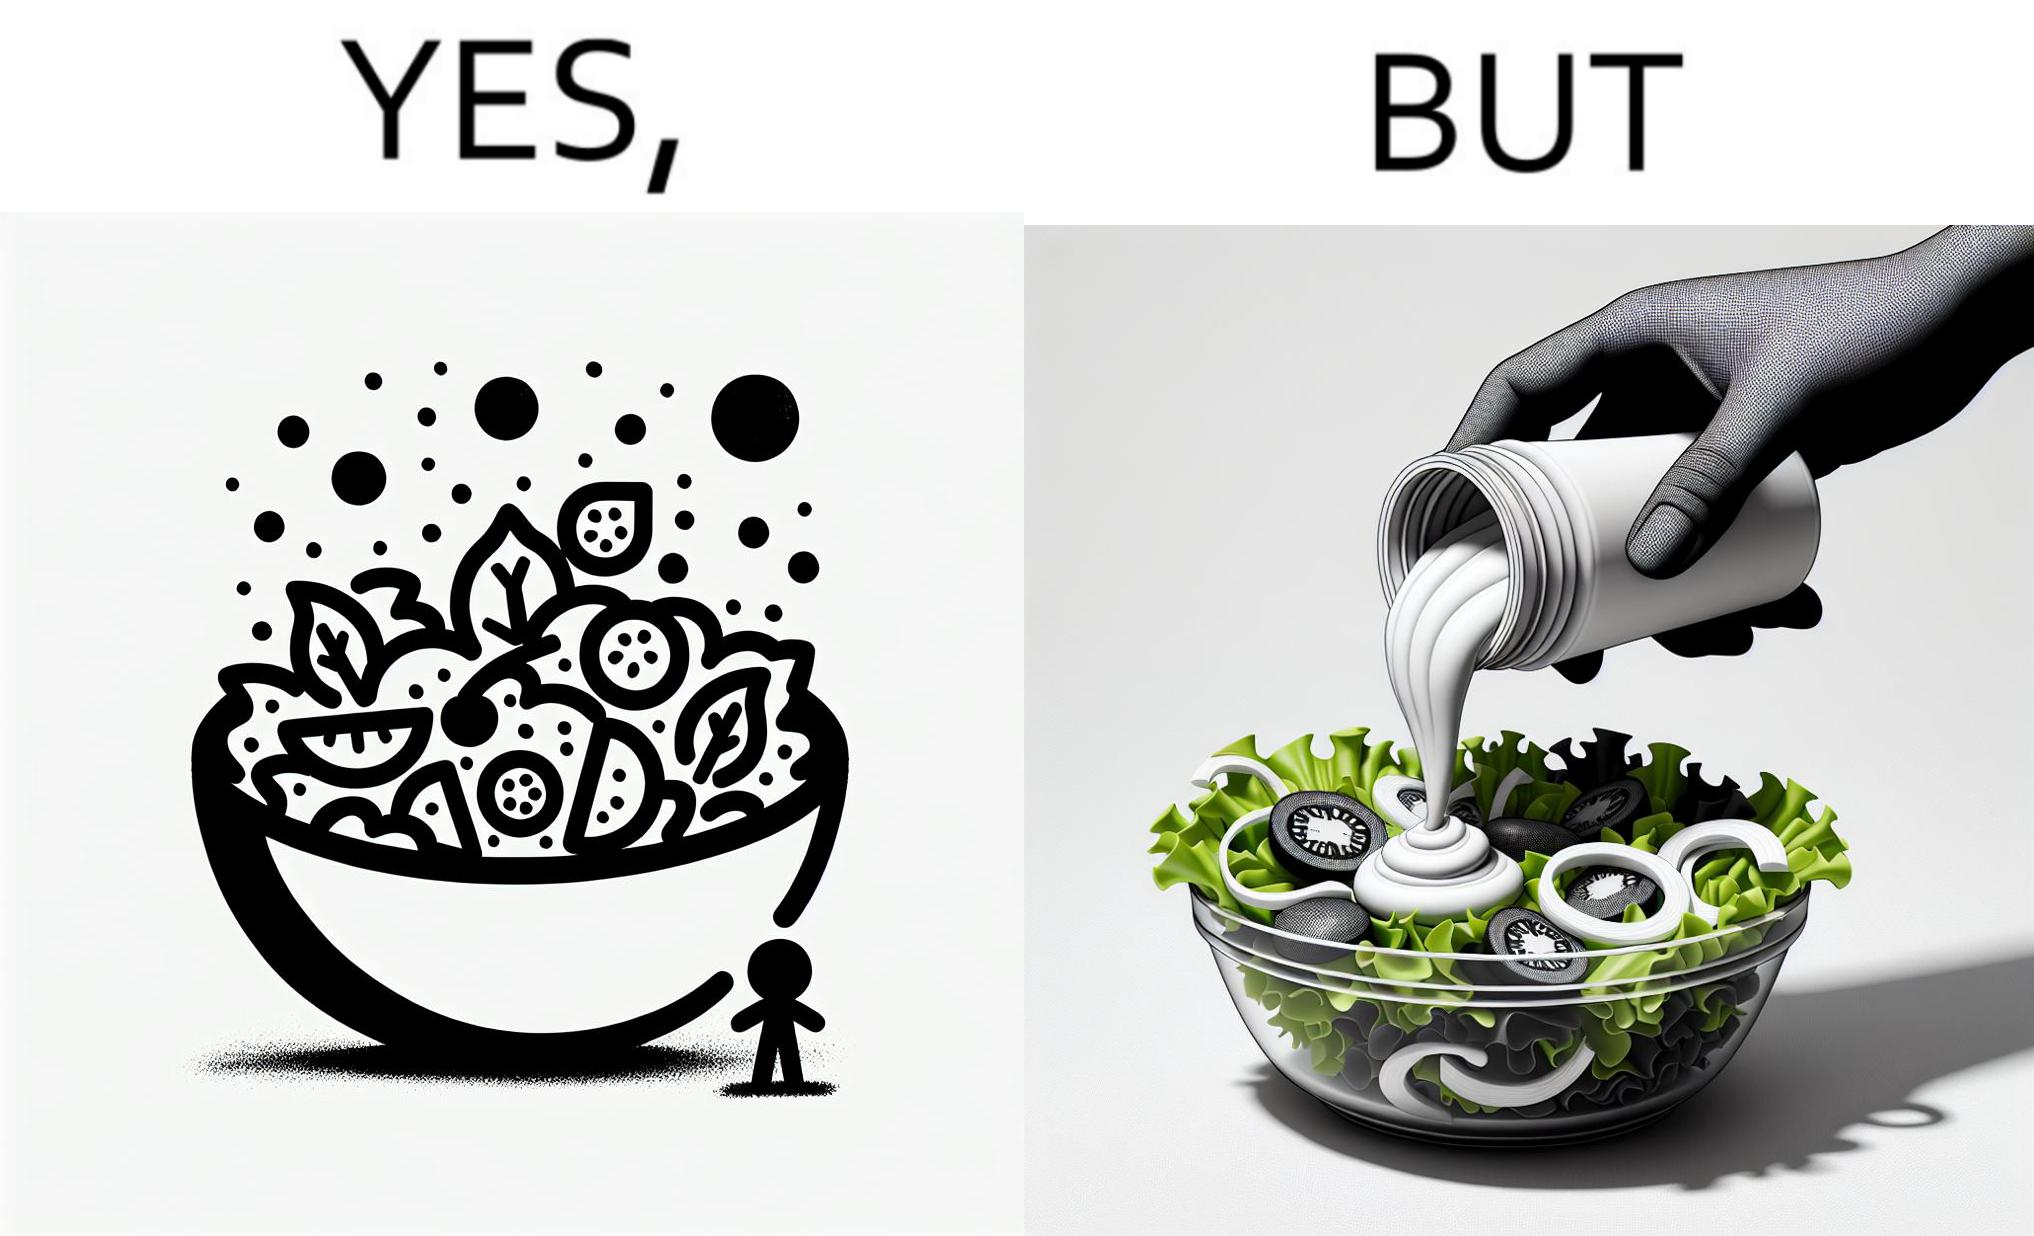What do you see in each half of this image? In the left part of the image: salad in a bowl In the right part of the image: pouring mayonnaise sauce on salad in a bowl 